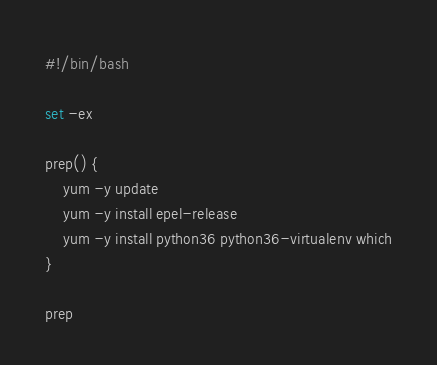<code> <loc_0><loc_0><loc_500><loc_500><_Bash_>#!/bin/bash

set -ex

prep() {
    yum -y update
    yum -y install epel-release
    yum -y install python36 python36-virtualenv which
}

prep
</code> 